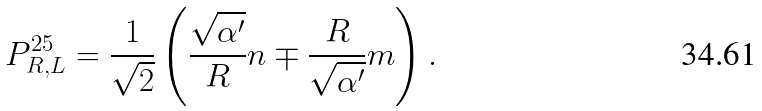Convert formula to latex. <formula><loc_0><loc_0><loc_500><loc_500>P ^ { 2 5 } _ { R , L } = \frac { 1 } { \sqrt { 2 } } \left ( \frac { \sqrt { \alpha ^ { \prime } } } { R } n \mp \frac { R } { \sqrt { \alpha ^ { \prime } } } m \right ) .</formula> 